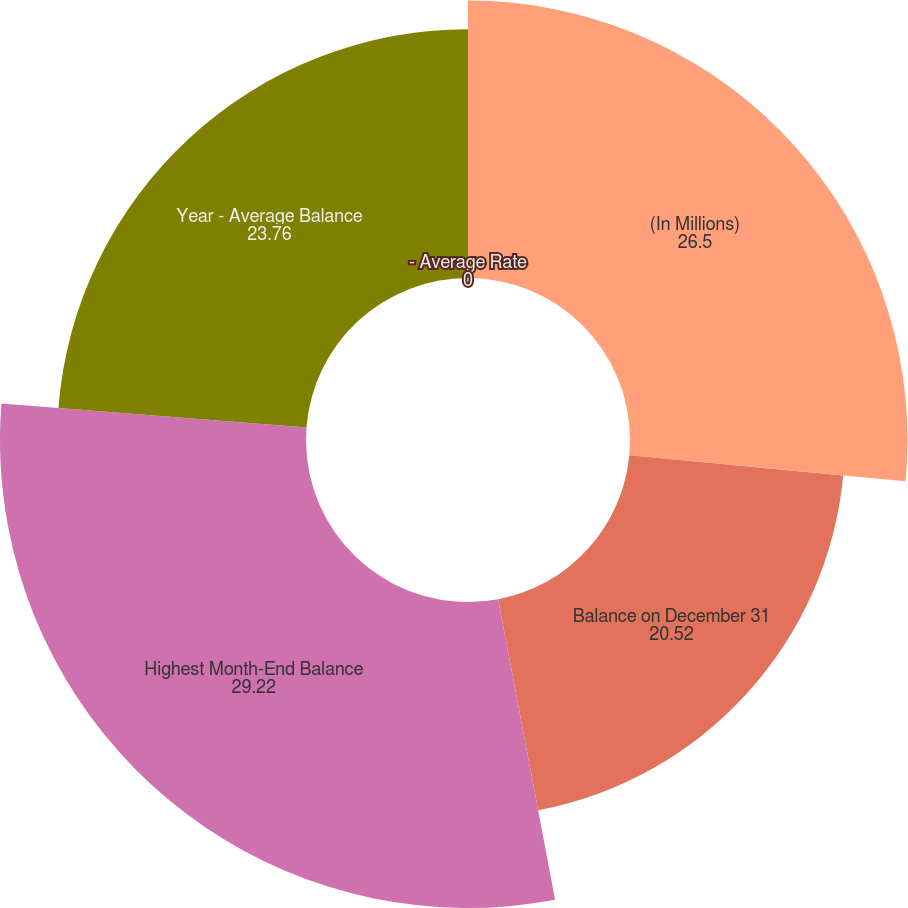Convert chart to OTSL. <chart><loc_0><loc_0><loc_500><loc_500><pie_chart><fcel>(In Millions)<fcel>Balance on December 31<fcel>Highest Month-End Balance<fcel>Year - Average Balance<fcel>- Average Rate<nl><fcel>26.5%<fcel>20.52%<fcel>29.22%<fcel>23.76%<fcel>0.0%<nl></chart> 